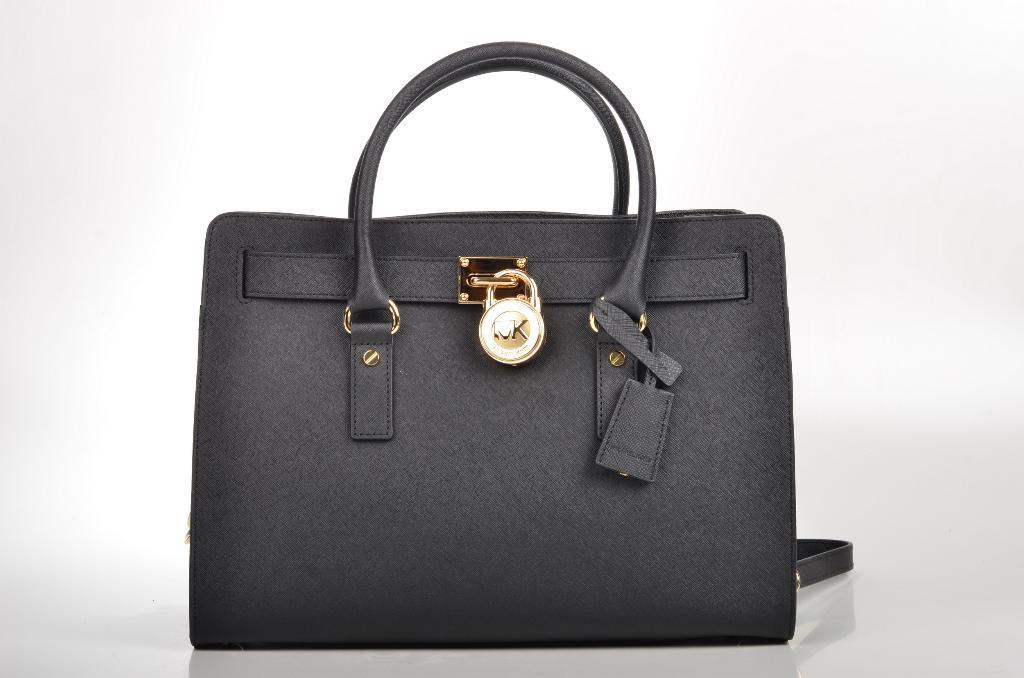What object can be seen in the image? There is a bag in the image. How many pies are being sliced by the blade on the bag in the image? There are no pies or blades present in the image; it only features a bag. 